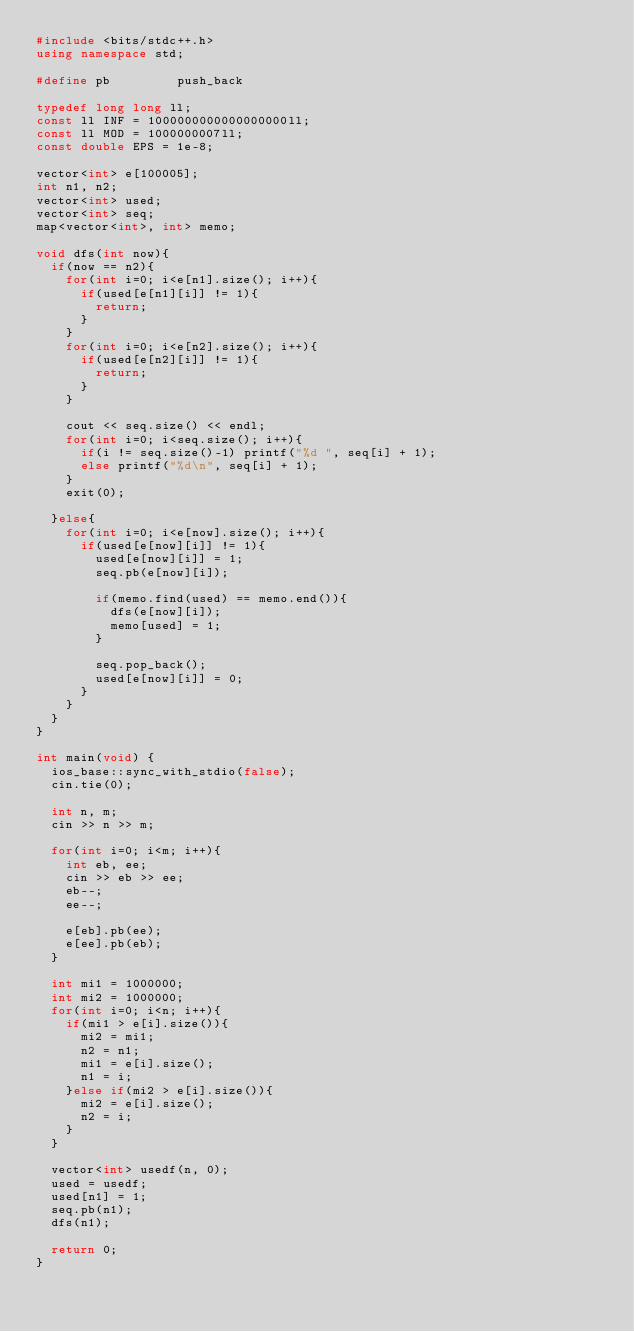<code> <loc_0><loc_0><loc_500><loc_500><_C++_>#include <bits/stdc++.h>
using namespace std;
 
#define pb         push_back
 
typedef long long ll;
const ll INF = 1000000000000000000ll;
const ll MOD = 1000000007ll;
const double EPS = 1e-8;
 
vector<int> e[100005];
int n1, n2;
vector<int> used;
vector<int> seq;
map<vector<int>, int> memo;
 
void dfs(int now){
	if(now == n2){
		for(int i=0; i<e[n1].size(); i++){
			if(used[e[n1][i]] != 1){
				return;
			}
		}
		for(int i=0; i<e[n2].size(); i++){
			if(used[e[n2][i]] != 1){
				return;
			}
		}
 
		cout << seq.size() << endl;
		for(int i=0; i<seq.size(); i++){
			if(i != seq.size()-1) printf("%d ", seq[i] + 1);
			else printf("%d\n", seq[i] + 1);
		}
		exit(0);
 
	}else{
		for(int i=0; i<e[now].size(); i++){
			if(used[e[now][i]] != 1){
				used[e[now][i]] = 1;
				seq.pb(e[now][i]);

				if(memo.find(used) == memo.end()){
					dfs(e[now][i]);
					memo[used] = 1;
				}

				seq.pop_back();
				used[e[now][i]] = 0;
			}
		}
	}
}
 
int main(void) {
	ios_base::sync_with_stdio(false);
	cin.tie(0);
	
	int n, m;
	cin >> n >> m;
 
	for(int i=0; i<m; i++){
		int eb, ee;
		cin >> eb >> ee;
		eb--;
		ee--;
 
		e[eb].pb(ee);
		e[ee].pb(eb);
	}
 
	int mi1 = 1000000;
	int mi2 = 1000000;
	for(int i=0; i<n; i++){
		if(mi1 > e[i].size()){
			mi2 = mi1;
			n2 = n1;
			mi1 = e[i].size();
			n1 = i;
		}else if(mi2 > e[i].size()){
			mi2 = e[i].size();
			n2 = i;
		}
	}
 
	vector<int> usedf(n, 0);
	used = usedf;
	used[n1] = 1;
	seq.pb(n1);
	dfs(n1);
	
	return 0;
}
</code> 